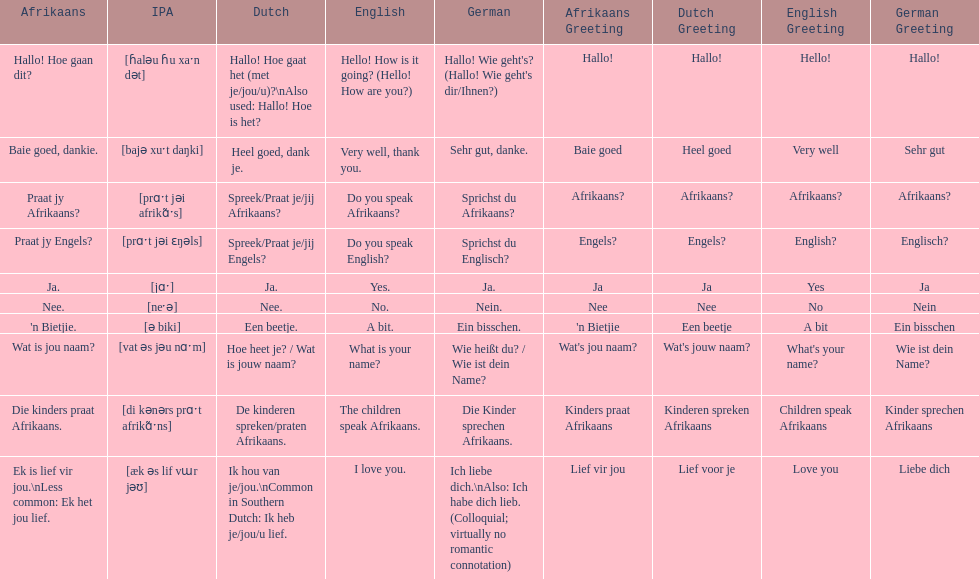How do you say "do you speak afrikaans?" in afrikaans? Praat jy Afrikaans?. 